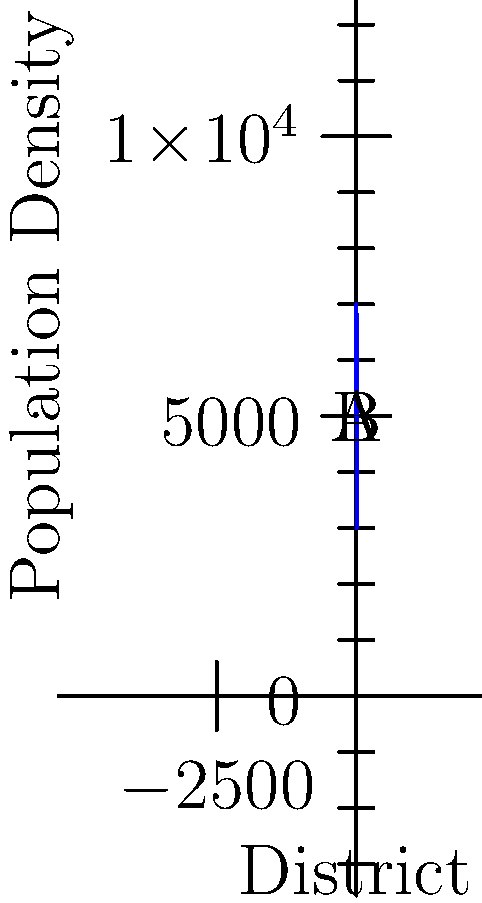The graph shows the population density (people per square mile) along a 6-mile stretch of your state, divided into districts. The population density function is given by $f(x) = 5000 + 2000\sin(\frac{\pi x}{3})$, where $x$ is the distance in miles from point A. Calculate the total population in the region between points A and B. How would this information help in ensuring fair representation in local government? To find the total population, we need to calculate the area under the curve from x = 0 to x = 6.

1) The area under the curve is given by the definite integral:

   $$\int_0^6 (5000 + 2000\sin(\frac{\pi x}{3})) dx$$

2) Let's integrate this function:
   
   $$\int_0^6 5000 dx + \int_0^6 2000\sin(\frac{\pi x}{3}) dx$$

3) The first part is straightforward:
   
   $$5000x|_0^6 = 30000$$

4) For the second part, we use u-substitution:
   Let $u = \frac{\pi x}{3}$, then $du = \frac{\pi}{3} dx$, and $dx = \frac{3}{\pi} du$

   $$2000 \cdot \frac{3}{\pi} \int_0^{2\pi} \sin(u) du = \frac{6000}{\pi} [-\cos(u)]_0^{2\pi}$$

5) Evaluating:
   
   $$\frac{6000}{\pi} [-\cos(2\pi) + \cos(0)] = \frac{6000}{\pi} [0] = 0$$

6) The total area is thus 30000 + 0 = 30000 square miles.

7) Since this represents the population density per square mile over 6 miles, we multiply by 6:

   Total population = 30000 * 6 = 180000 people

This information helps ensure fair representation by providing an accurate count of the population in each district. It allows for the creation of districts with roughly equal populations, adhering to the principle of "one person, one vote" and preventing gerrymandering based on population density variations.
Answer: 180,000 people 